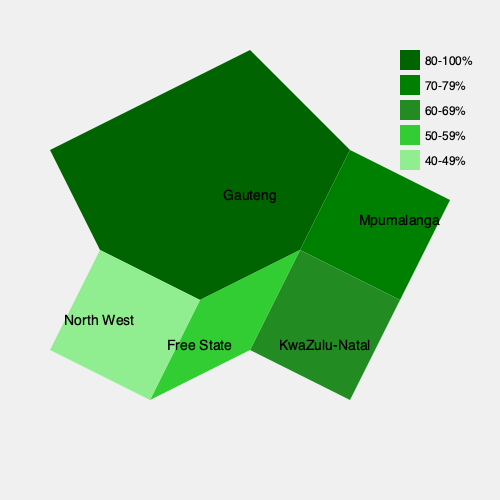Based on the choropleth map of ANC support across South African provinces, which province shows the highest level of support for the ANC, and how does this compare to the support in the Free State province? To answer this question, we need to analyze the choropleth map and compare the color-coded levels of ANC support across the provinces shown:

1. Identify the color scheme:
   - Darkest green (#006400): 80-100% support
   - Dark green (#008000): 70-79% support
   - Medium green (#228B22): 60-69% support
   - Light green (#32CD32): 50-59% support
   - Lightest green (#90EE90): 40-49% support

2. Locate the provinces on the map:
   - Gauteng: Central
   - Mpumalanga: Northeast
   - KwaZulu-Natal: Southeast
   - Free State: South-central
   - North West: West

3. Analyze the support levels:
   - Gauteng is colored in the darkest green, indicating 80-100% support.
   - Free State is colored in light green, indicating 50-59% support.

4. Compare Gauteng to Free State:
   - Gauteng has the highest level of support (80-100%).
   - Free State has a much lower level of support (50-59%).
   - The difference in support is at least 21 percentage points (minimum 80% vs. maximum 59%).

Therefore, Gauteng shows the highest level of support for the ANC, with at least 80% support, while the Free State shows significantly lower support, between 50-59%.
Answer: Gauteng has the highest ANC support (80-100%), which is at least 21 percentage points higher than Free State (50-59%). 